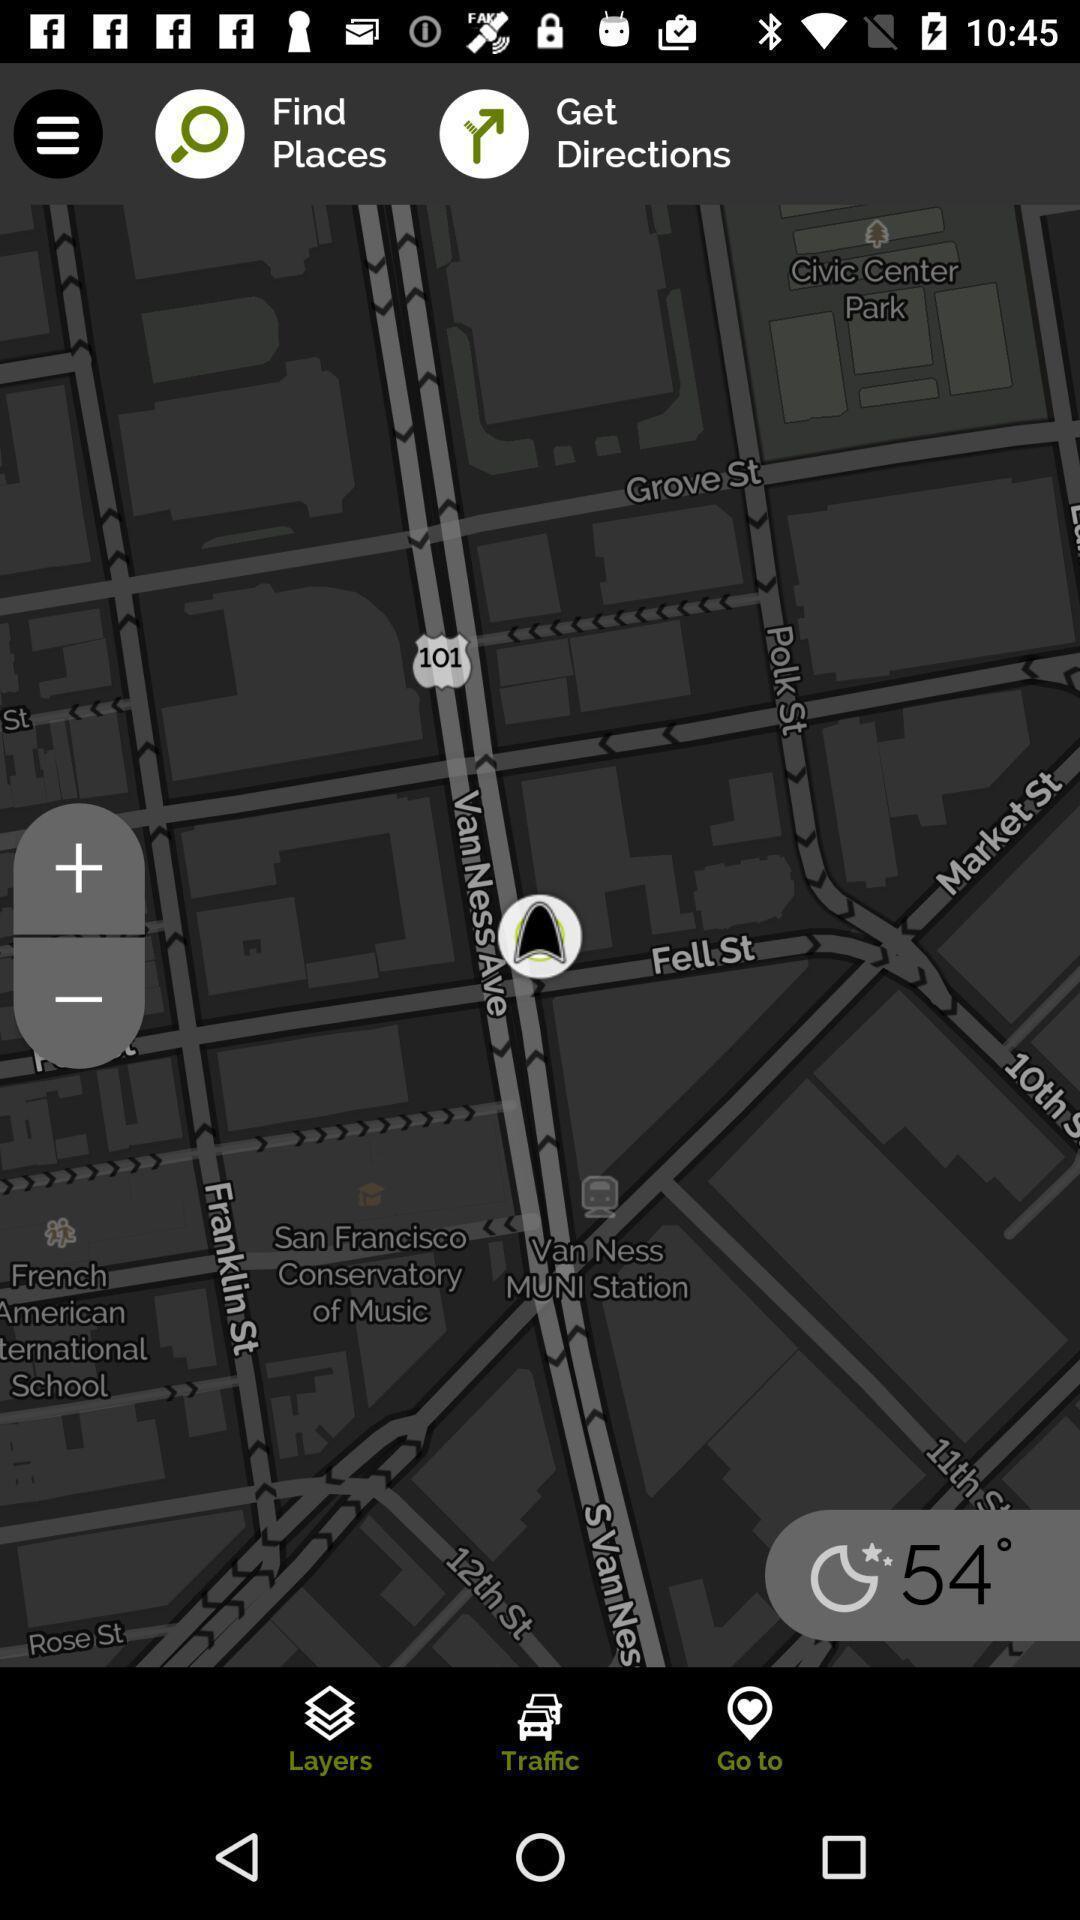Describe the key features of this screenshot. Page showing search bar to find locations. 